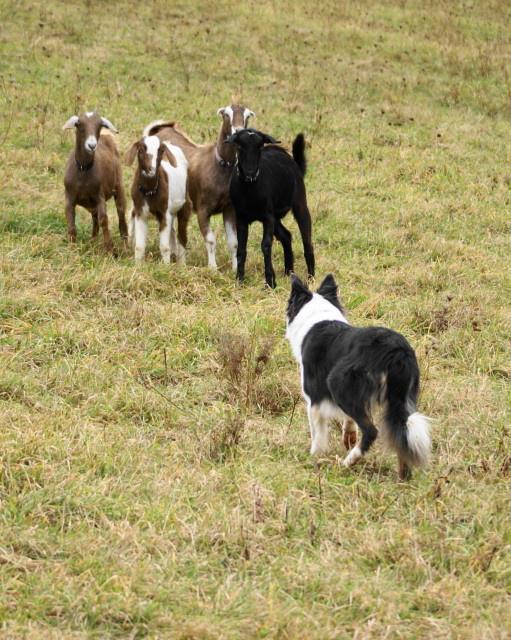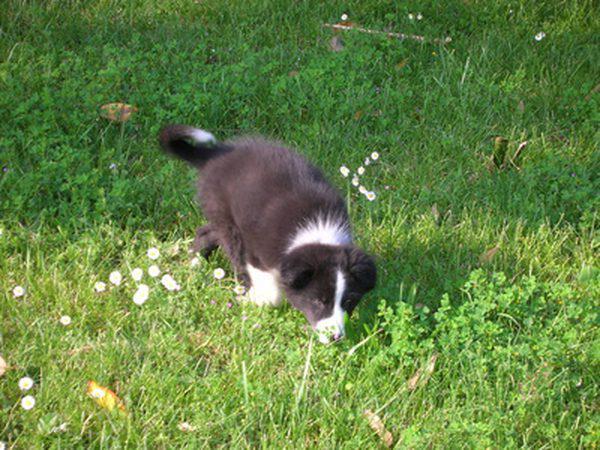The first image is the image on the left, the second image is the image on the right. For the images shown, is this caption "One image shows a black-and-white dog herding livestock, and the other shows one puppy in bright green grass near wildflowers." true? Answer yes or no. Yes. 